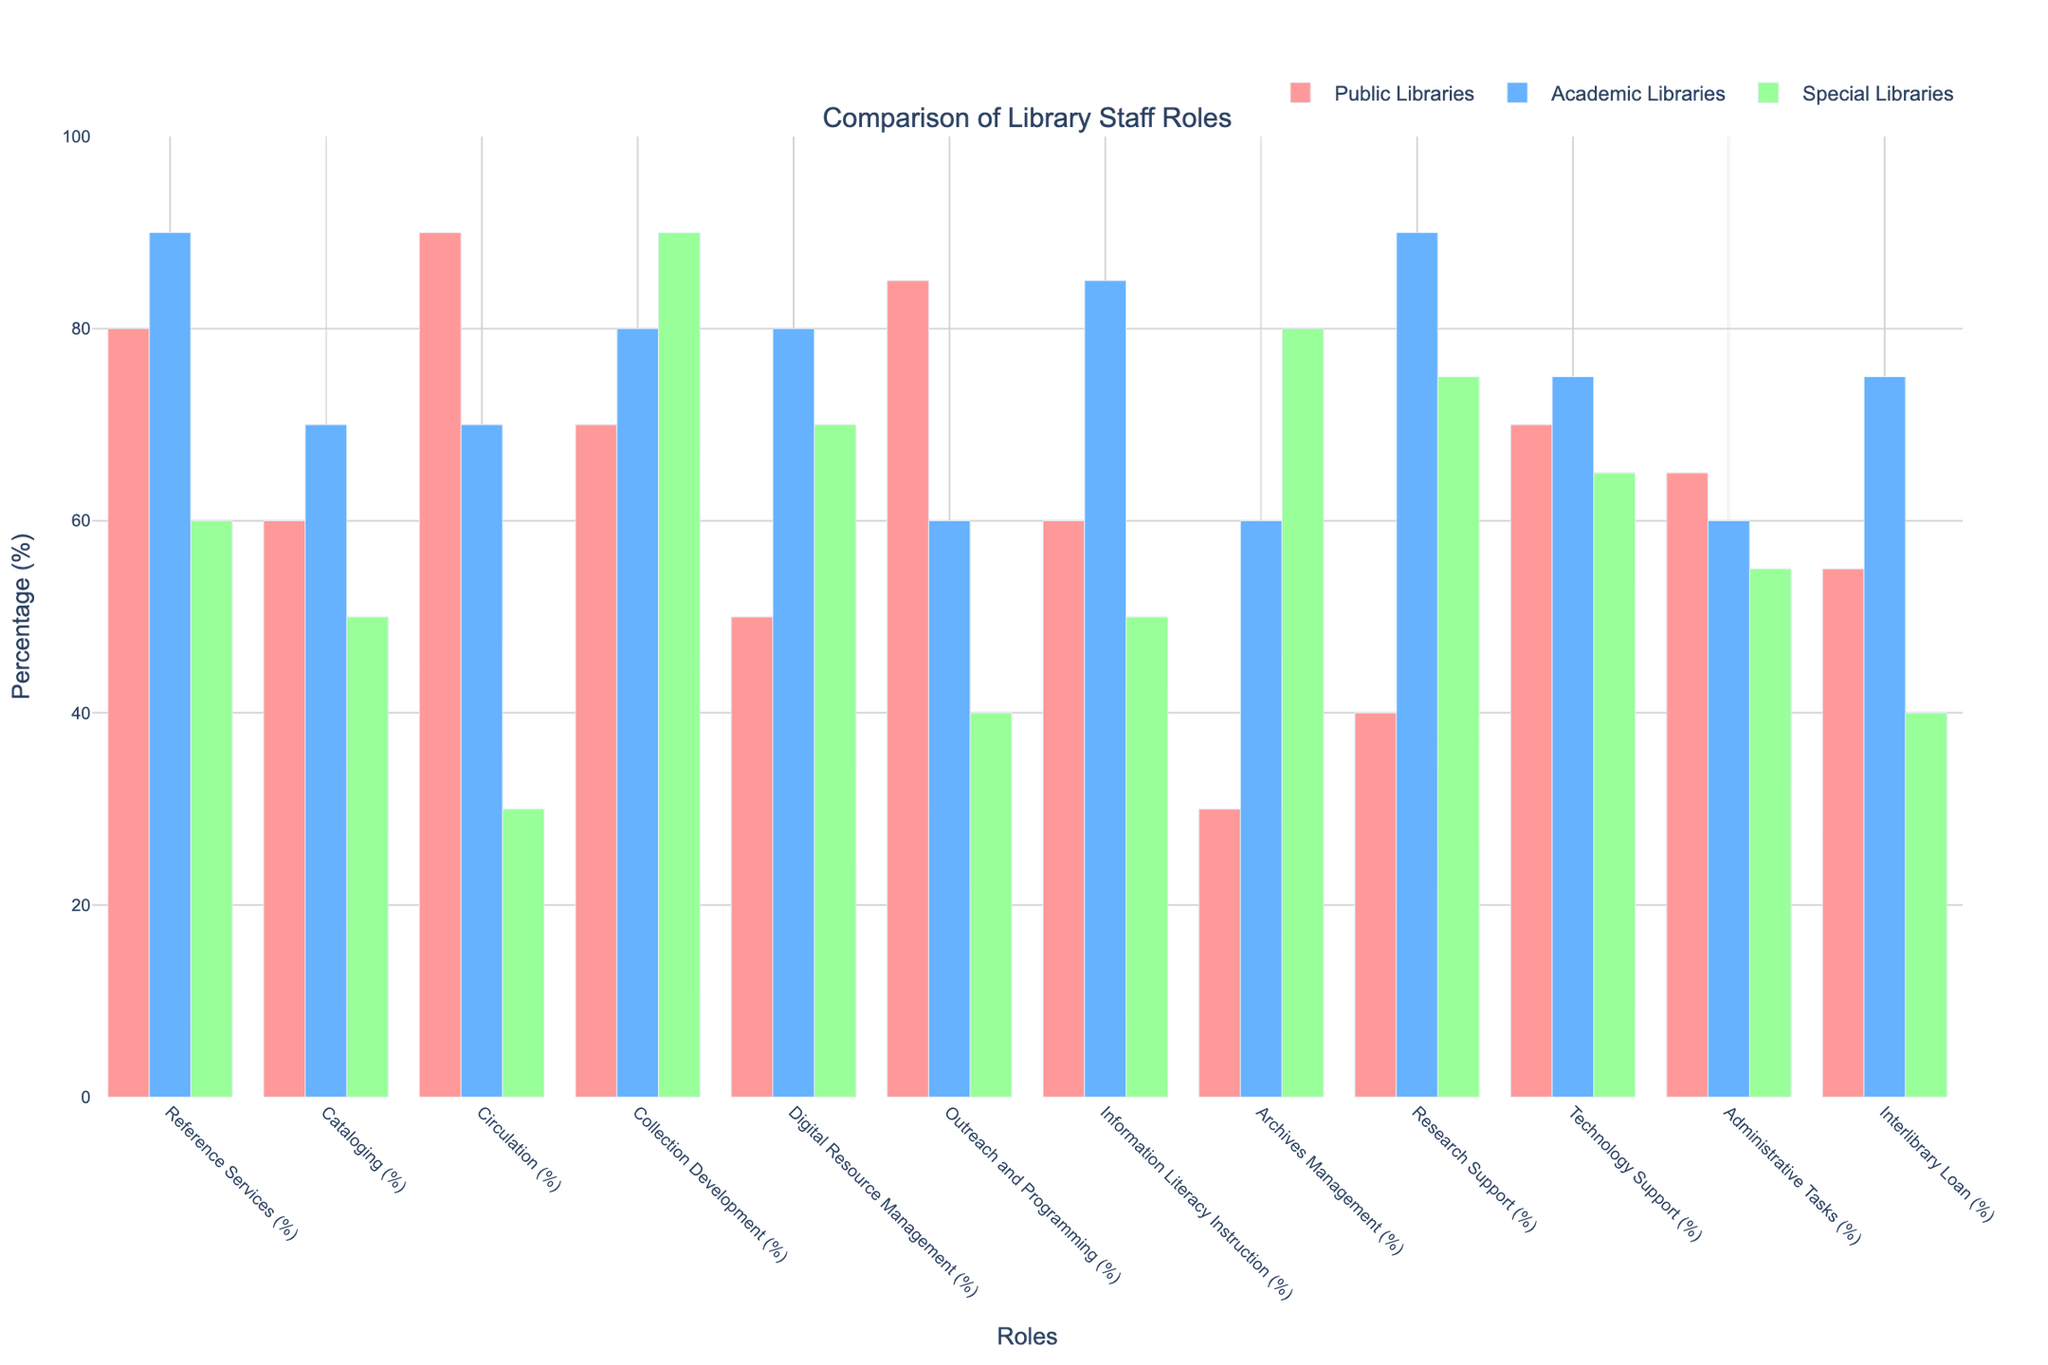Which role has the highest percentage of staff in public libraries? First, locate the bars corresponding to each role for public libraries (red bars). Find the bar with the highest height, which represents the highest percentage. The role with the highest bar for public libraries has the highest percentage of staff.
Answer: Circulation Which library type has the lowest percentage of staff in Outreach and Programming? Look at the bars representing Outreach and Programming for each library type (public in red, academic in blue, special in green). Identify the shortest bar for this role, indicating the lowest percentage.
Answer: Special Libraries What's the difference in the percentage of staff involved in Reference Services between public and special libraries? Find the percentages for Reference Services in public and special libraries (80% and 60% respectively). Subtract the percentage of special libraries from the percentage of public libraries (80% - 60%).
Answer: 20% Which role has the most balanced distribution across all three types of libraries? Examine the height of bars for each role and identify which role has bars of similar heights across all three library types, indicating a balanced distribution.
Answer: Technology Support Comparing Information Literacy Instruction, which library type has the highest percentage and by how much is it higher than the next highest? Locate the bars for Information Literacy Instruction. The tallest bar represents the highest percentage (academic libraries at 85%). Compare this with the second highest (public libraries at 60%) and calculate the difference (85% - 60%).
Answer: Academic Libraries by 25% Which role does special libraries have the highest percentage of staff compared to the other two library types? For each role, compare the height of the bar for special libraries (green) with the corresponding bars for public (red) and academic (blue) libraries. Identify the highest percentage that special libraries have over others.
Answer: Archives Management How do the percentages of staff involved in Collection Development compare between public and academic libraries? Look at the bars representing Collection Development for public (red) and academic (blue) libraries. Compare their heights to see which has a higher percentage (academic libraries at 80% and public libraries at 70%).
Answer: Academic Libraries have a higher percentage by 10% What is the sum of the percentages for Administrative Tasks across all three library types? Identify the percentage for Administrative Tasks in each library type (public - 65%, academic - 60%, special - 55%). Add these percentages together (65 + 60 + 55).
Answer: 180% Between Research Support and Digital Resource Management, which role has a more varied percentage distribution across the three library types? Compare the heights of bars for Research Support and Digital Resource Management across all three library types. The role with more variation in bar heights indicates a more varied distribution.
Answer: Research Support In which role does academic libraries have a higher percentage than special libraries, but a lower percentage than public libraries? Compare the bars for academic (blue) and special libraries (green) with those of public libraries (red) for each role. Identify where the academic libraries' percentage is between that of the other two.
Answer: Circulation 